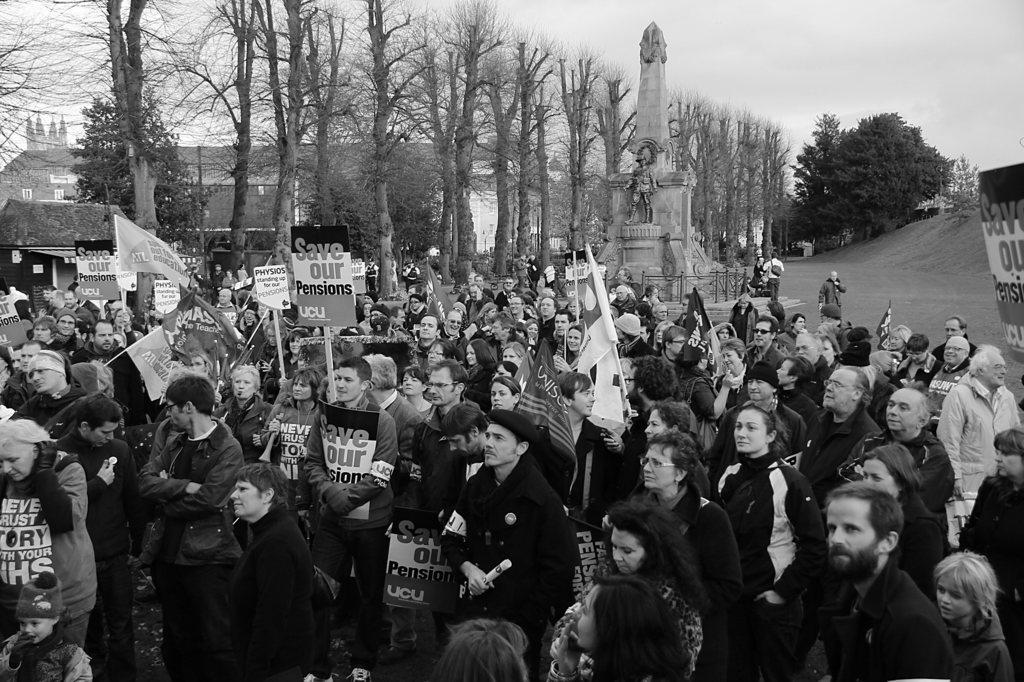How many people are present in the image? There are people in the image, but the exact number is not specified. What are some people holding in the image? Some people are holding boards and some are holding bags. What can be seen in the background of the image? There are trees, buildings, and a pillar in the background of the image. How many giants can be seen interacting with the cattle in the image? There are no giants or cattle present in the image. What type of quarter is visible on the board held by one of the people in the image? There is no mention of a quarter or any specific item on the boards held by the people in the image. 